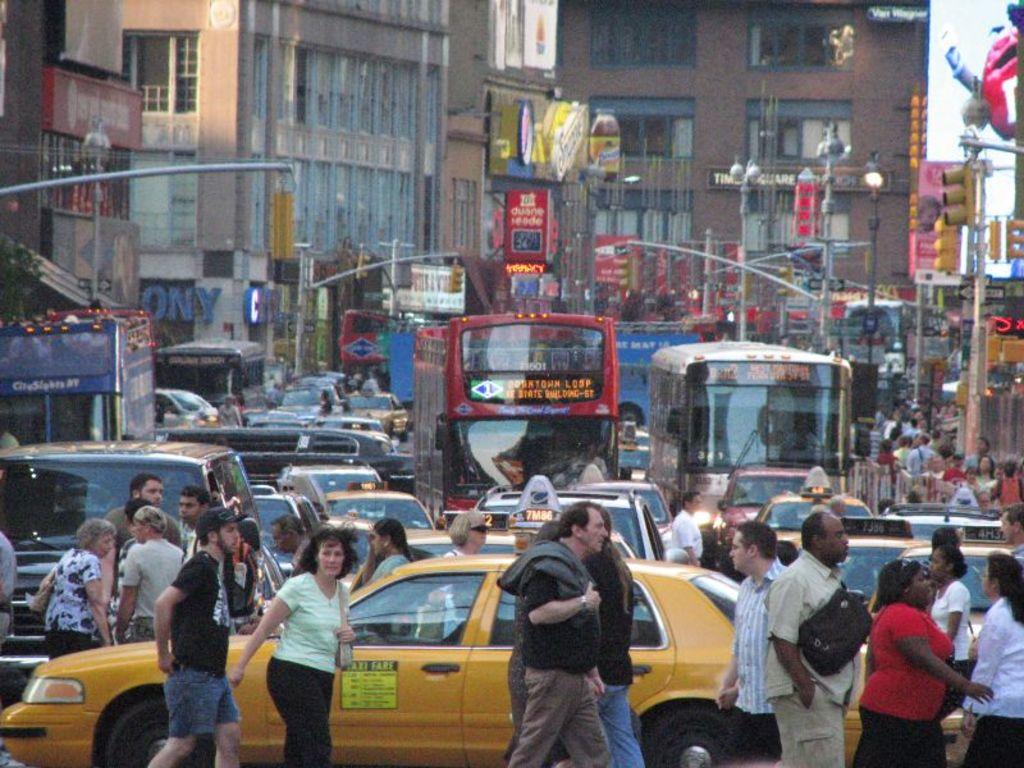What does the sign on the taxi say?
Make the answer very short. Taxi fare. 